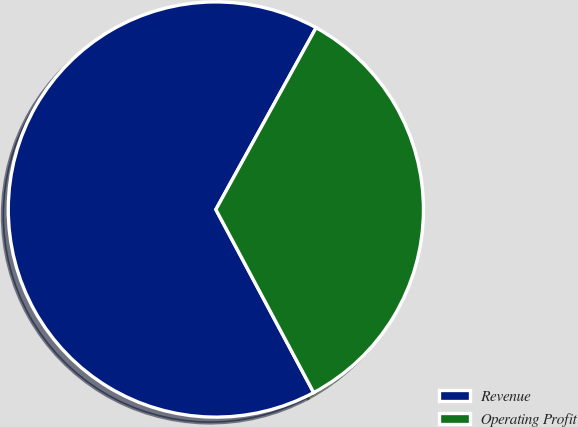Convert chart to OTSL. <chart><loc_0><loc_0><loc_500><loc_500><pie_chart><fcel>Revenue<fcel>Operating Profit<nl><fcel>65.83%<fcel>34.17%<nl></chart> 